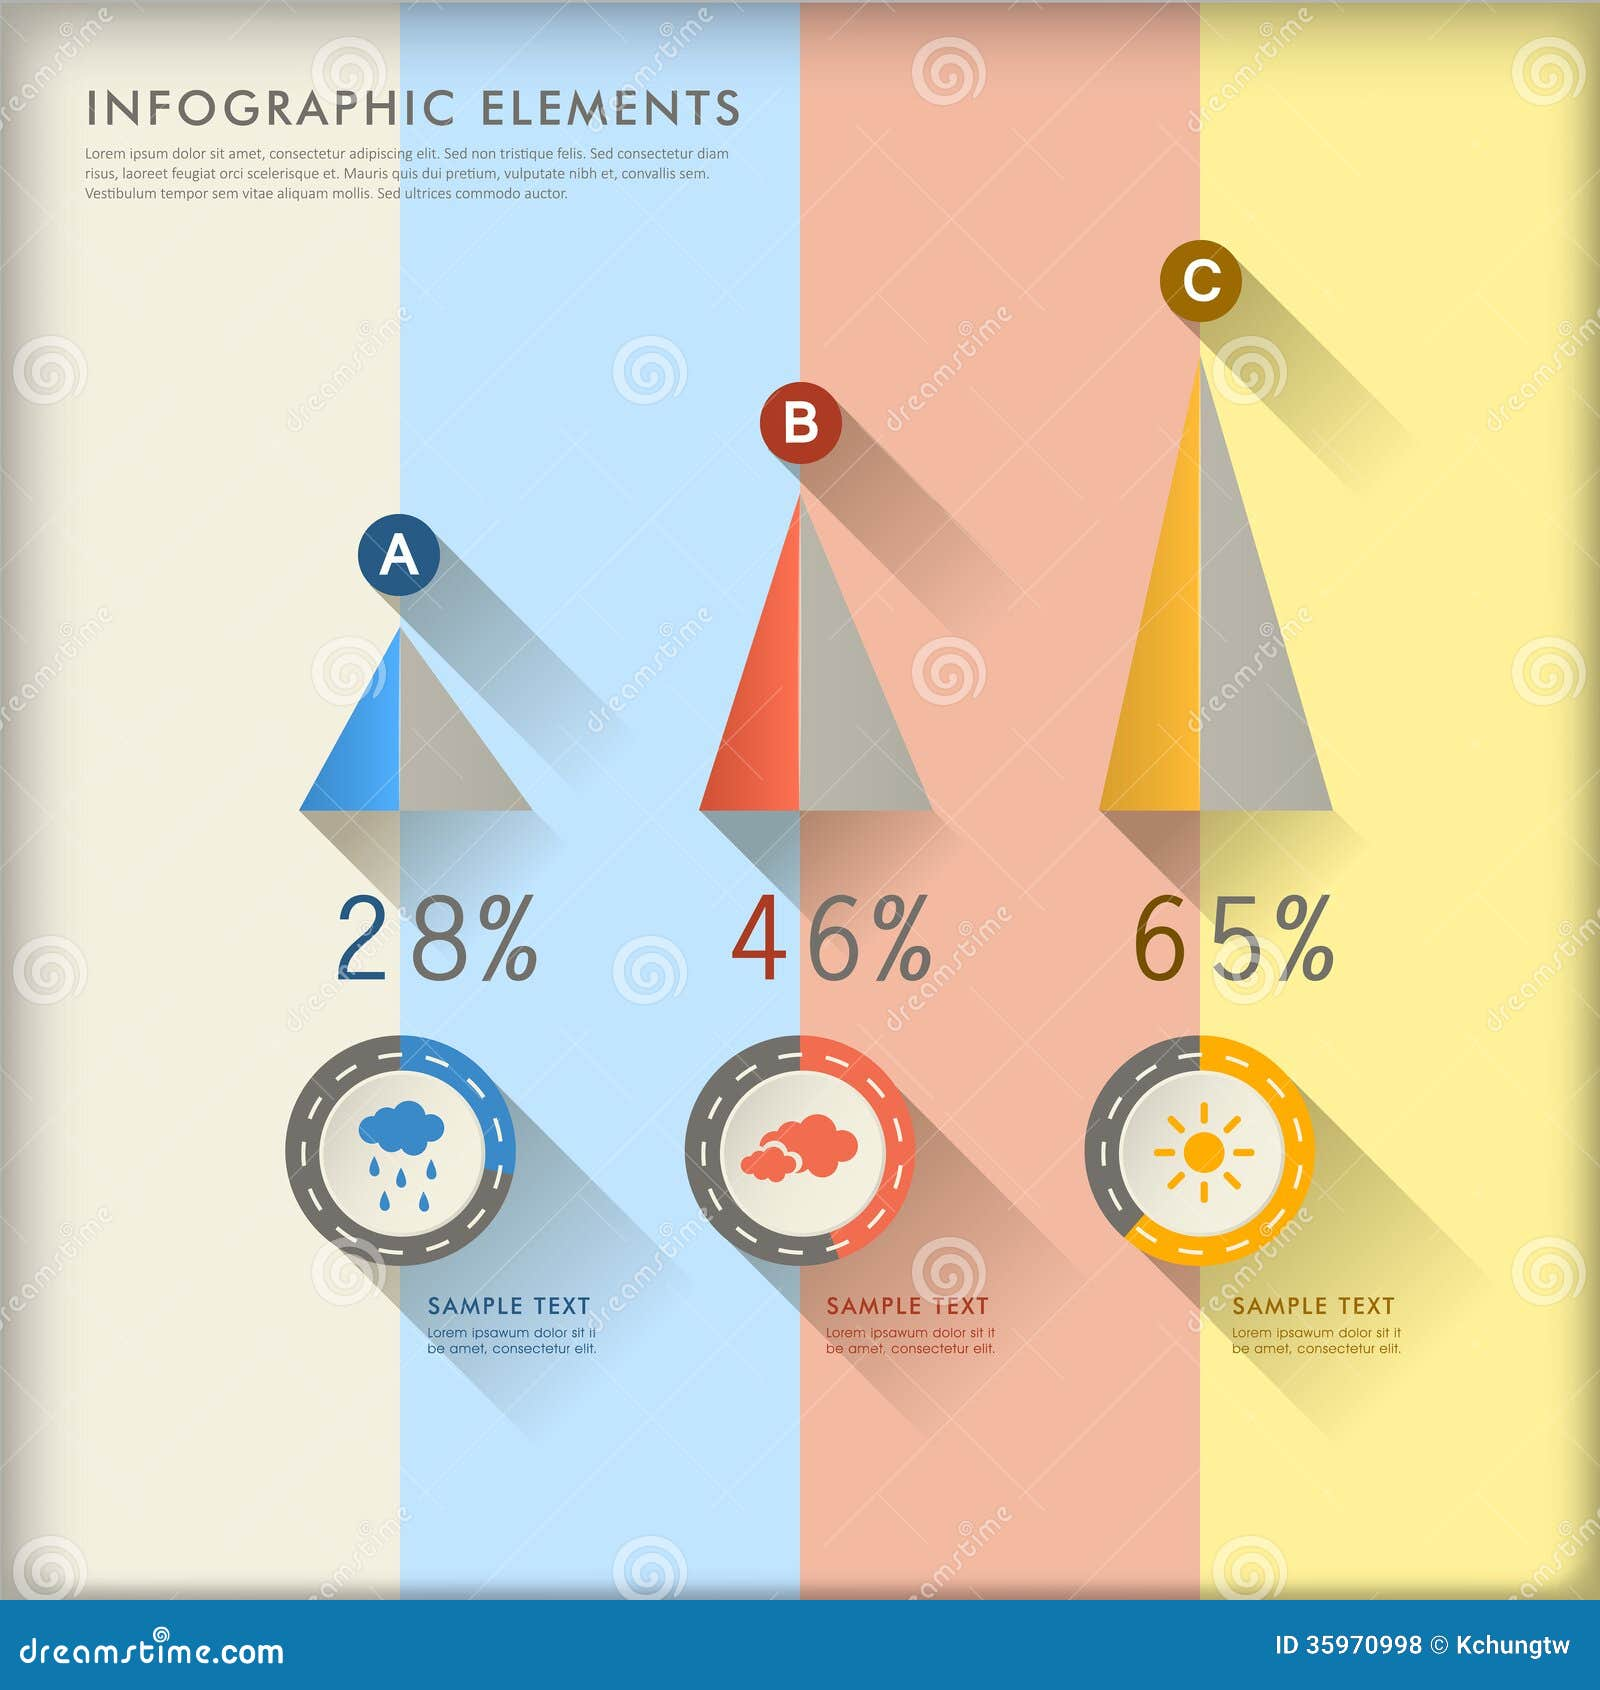What message does the layout and structure of this infographic imply about data visualization? The layout and structure of this infographic highlight the importance of simplicity and clarity in data visualization. By using distinct icons and a clear color code for each category, combined with ascending pyramid shapes and percentages, the infographic effectively conveys the key message at a single glance. It shows that visual elements like shapes, colors, and minimalistic design can facilitate easy comprehension and comparison of data, making it accessible to a broad audience. 